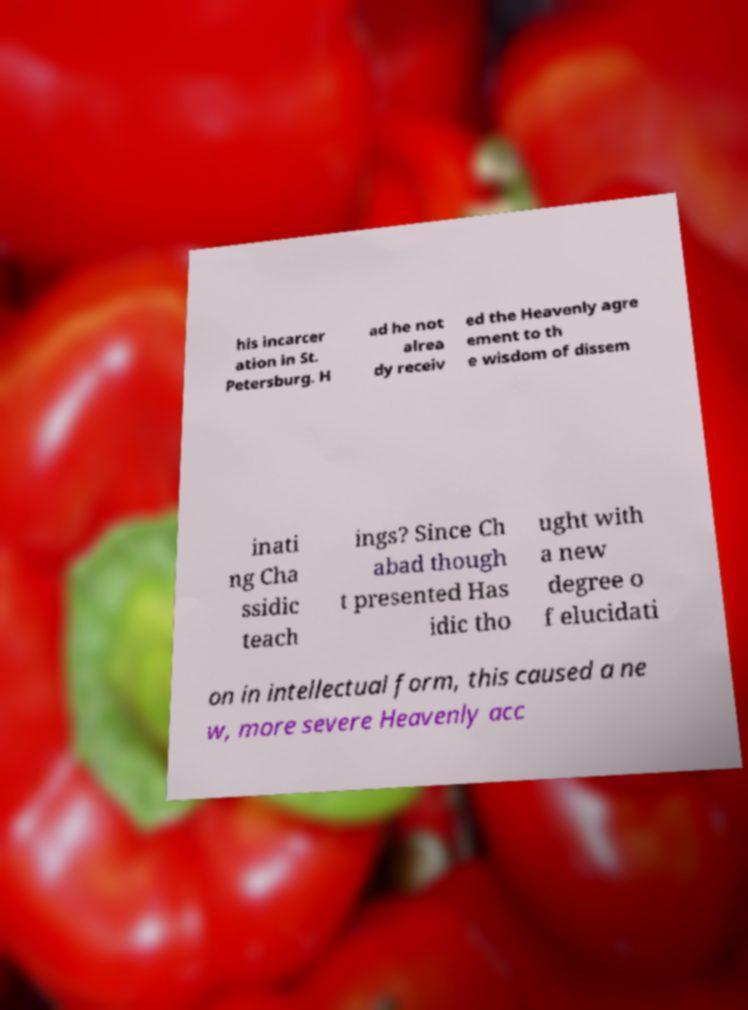For documentation purposes, I need the text within this image transcribed. Could you provide that? his incarcer ation in St. Petersburg. H ad he not alrea dy receiv ed the Heavenly agre ement to th e wisdom of dissem inati ng Cha ssidic teach ings? Since Ch abad though t presented Has idic tho ught with a new degree o f elucidati on in intellectual form, this caused a ne w, more severe Heavenly acc 